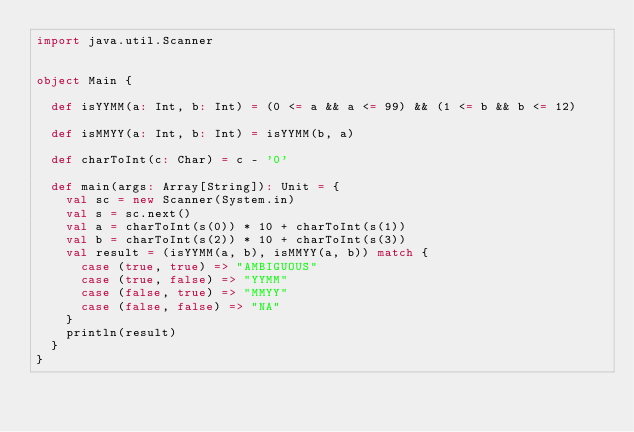Convert code to text. <code><loc_0><loc_0><loc_500><loc_500><_Scala_>import java.util.Scanner


object Main {

  def isYYMM(a: Int, b: Int) = (0 <= a && a <= 99) && (1 <= b && b <= 12)

  def isMMYY(a: Int, b: Int) = isYYMM(b, a)

  def charToInt(c: Char) = c - '0'

  def main(args: Array[String]): Unit = {
    val sc = new Scanner(System.in)
    val s = sc.next()
    val a = charToInt(s(0)) * 10 + charToInt(s(1))
    val b = charToInt(s(2)) * 10 + charToInt(s(3))
    val result = (isYYMM(a, b), isMMYY(a, b)) match {
      case (true, true) => "AMBIGUOUS"
      case (true, false) => "YYMM"
      case (false, true) => "MMYY"
      case (false, false) => "NA"
    }
    println(result)
  }
}</code> 